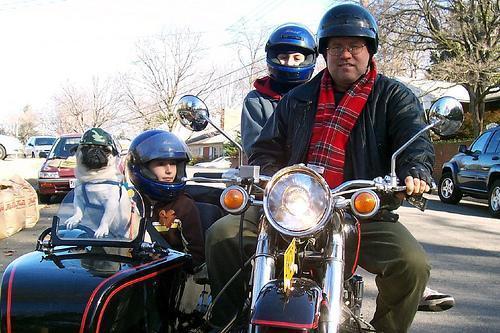How many people are in the photo?
Give a very brief answer. 3. How many people are riding the motorcycle?
Give a very brief answer. 3. How many people are there?
Give a very brief answer. 3. How many cars can you see?
Give a very brief answer. 2. How many slices of pizza are left on the closest pan?
Give a very brief answer. 0. 